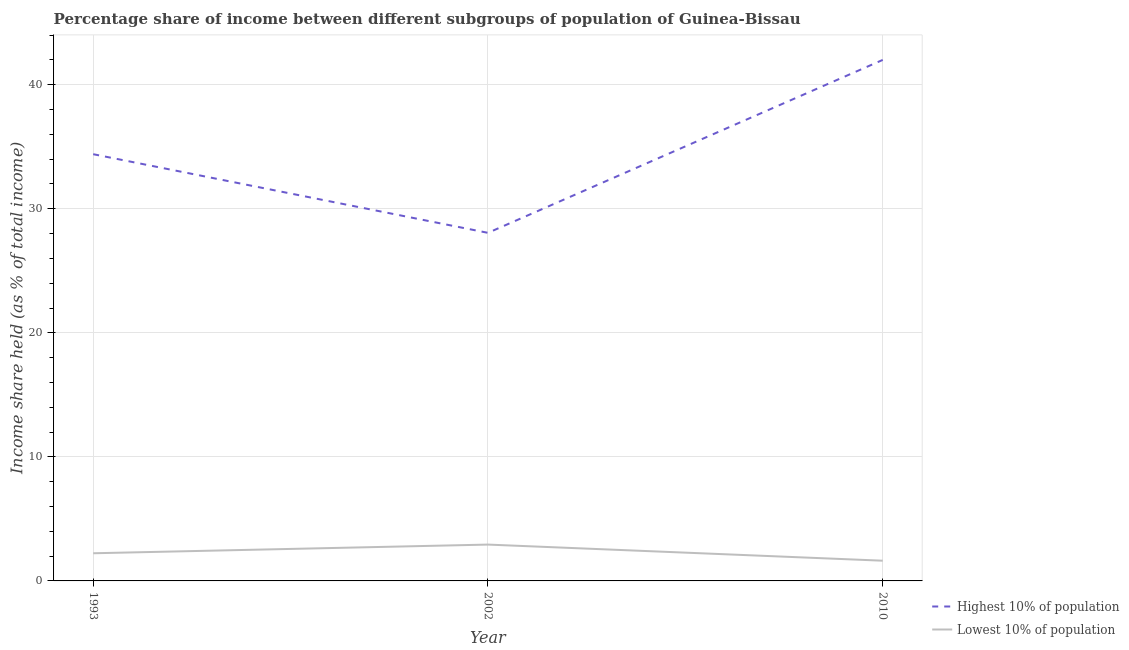Does the line corresponding to income share held by lowest 10% of the population intersect with the line corresponding to income share held by highest 10% of the population?
Provide a short and direct response. No. What is the income share held by lowest 10% of the population in 2002?
Give a very brief answer. 2.93. Across all years, what is the maximum income share held by highest 10% of the population?
Offer a terse response. 42. Across all years, what is the minimum income share held by highest 10% of the population?
Make the answer very short. 28.06. In which year was the income share held by lowest 10% of the population maximum?
Your answer should be very brief. 2002. In which year was the income share held by highest 10% of the population minimum?
Offer a very short reply. 2002. What is the total income share held by lowest 10% of the population in the graph?
Provide a short and direct response. 6.79. What is the difference between the income share held by lowest 10% of the population in 2002 and that in 2010?
Offer a terse response. 1.3. What is the difference between the income share held by lowest 10% of the population in 1993 and the income share held by highest 10% of the population in 2010?
Keep it short and to the point. -39.77. What is the average income share held by highest 10% of the population per year?
Your answer should be very brief. 34.82. In the year 2010, what is the difference between the income share held by lowest 10% of the population and income share held by highest 10% of the population?
Give a very brief answer. -40.37. What is the ratio of the income share held by highest 10% of the population in 1993 to that in 2010?
Your answer should be very brief. 0.82. Is the income share held by lowest 10% of the population in 1993 less than that in 2002?
Your response must be concise. Yes. Is the difference between the income share held by lowest 10% of the population in 1993 and 2010 greater than the difference between the income share held by highest 10% of the population in 1993 and 2010?
Offer a very short reply. Yes. What is the difference between the highest and the second highest income share held by highest 10% of the population?
Offer a very short reply. 7.6. What is the difference between the highest and the lowest income share held by highest 10% of the population?
Keep it short and to the point. 13.94. In how many years, is the income share held by lowest 10% of the population greater than the average income share held by lowest 10% of the population taken over all years?
Offer a terse response. 1. Does the income share held by lowest 10% of the population monotonically increase over the years?
Make the answer very short. No. Is the income share held by lowest 10% of the population strictly greater than the income share held by highest 10% of the population over the years?
Provide a short and direct response. No. Is the income share held by highest 10% of the population strictly less than the income share held by lowest 10% of the population over the years?
Provide a succinct answer. No. How many lines are there?
Provide a short and direct response. 2. Are the values on the major ticks of Y-axis written in scientific E-notation?
Provide a succinct answer. No. Where does the legend appear in the graph?
Keep it short and to the point. Bottom right. How many legend labels are there?
Give a very brief answer. 2. What is the title of the graph?
Provide a succinct answer. Percentage share of income between different subgroups of population of Guinea-Bissau. Does "Chemicals" appear as one of the legend labels in the graph?
Offer a very short reply. No. What is the label or title of the X-axis?
Your answer should be very brief. Year. What is the label or title of the Y-axis?
Give a very brief answer. Income share held (as % of total income). What is the Income share held (as % of total income) of Highest 10% of population in 1993?
Keep it short and to the point. 34.4. What is the Income share held (as % of total income) in Lowest 10% of population in 1993?
Make the answer very short. 2.23. What is the Income share held (as % of total income) of Highest 10% of population in 2002?
Offer a terse response. 28.06. What is the Income share held (as % of total income) in Lowest 10% of population in 2002?
Your answer should be very brief. 2.93. What is the Income share held (as % of total income) of Highest 10% of population in 2010?
Provide a short and direct response. 42. What is the Income share held (as % of total income) in Lowest 10% of population in 2010?
Your answer should be very brief. 1.63. Across all years, what is the maximum Income share held (as % of total income) of Highest 10% of population?
Provide a succinct answer. 42. Across all years, what is the maximum Income share held (as % of total income) in Lowest 10% of population?
Provide a short and direct response. 2.93. Across all years, what is the minimum Income share held (as % of total income) in Highest 10% of population?
Your answer should be compact. 28.06. Across all years, what is the minimum Income share held (as % of total income) in Lowest 10% of population?
Provide a succinct answer. 1.63. What is the total Income share held (as % of total income) in Highest 10% of population in the graph?
Offer a terse response. 104.46. What is the total Income share held (as % of total income) in Lowest 10% of population in the graph?
Offer a terse response. 6.79. What is the difference between the Income share held (as % of total income) in Highest 10% of population in 1993 and that in 2002?
Offer a very short reply. 6.34. What is the difference between the Income share held (as % of total income) in Lowest 10% of population in 1993 and that in 2002?
Make the answer very short. -0.7. What is the difference between the Income share held (as % of total income) of Highest 10% of population in 1993 and that in 2010?
Provide a short and direct response. -7.6. What is the difference between the Income share held (as % of total income) in Lowest 10% of population in 1993 and that in 2010?
Make the answer very short. 0.6. What is the difference between the Income share held (as % of total income) in Highest 10% of population in 2002 and that in 2010?
Ensure brevity in your answer.  -13.94. What is the difference between the Income share held (as % of total income) of Highest 10% of population in 1993 and the Income share held (as % of total income) of Lowest 10% of population in 2002?
Keep it short and to the point. 31.47. What is the difference between the Income share held (as % of total income) in Highest 10% of population in 1993 and the Income share held (as % of total income) in Lowest 10% of population in 2010?
Provide a succinct answer. 32.77. What is the difference between the Income share held (as % of total income) of Highest 10% of population in 2002 and the Income share held (as % of total income) of Lowest 10% of population in 2010?
Offer a very short reply. 26.43. What is the average Income share held (as % of total income) in Highest 10% of population per year?
Your answer should be compact. 34.82. What is the average Income share held (as % of total income) in Lowest 10% of population per year?
Your answer should be compact. 2.26. In the year 1993, what is the difference between the Income share held (as % of total income) of Highest 10% of population and Income share held (as % of total income) of Lowest 10% of population?
Offer a very short reply. 32.17. In the year 2002, what is the difference between the Income share held (as % of total income) in Highest 10% of population and Income share held (as % of total income) in Lowest 10% of population?
Provide a succinct answer. 25.13. In the year 2010, what is the difference between the Income share held (as % of total income) of Highest 10% of population and Income share held (as % of total income) of Lowest 10% of population?
Your response must be concise. 40.37. What is the ratio of the Income share held (as % of total income) in Highest 10% of population in 1993 to that in 2002?
Give a very brief answer. 1.23. What is the ratio of the Income share held (as % of total income) in Lowest 10% of population in 1993 to that in 2002?
Keep it short and to the point. 0.76. What is the ratio of the Income share held (as % of total income) in Highest 10% of population in 1993 to that in 2010?
Provide a short and direct response. 0.82. What is the ratio of the Income share held (as % of total income) of Lowest 10% of population in 1993 to that in 2010?
Your response must be concise. 1.37. What is the ratio of the Income share held (as % of total income) of Highest 10% of population in 2002 to that in 2010?
Your answer should be very brief. 0.67. What is the ratio of the Income share held (as % of total income) of Lowest 10% of population in 2002 to that in 2010?
Ensure brevity in your answer.  1.8. What is the difference between the highest and the second highest Income share held (as % of total income) in Highest 10% of population?
Offer a terse response. 7.6. What is the difference between the highest and the lowest Income share held (as % of total income) of Highest 10% of population?
Keep it short and to the point. 13.94. What is the difference between the highest and the lowest Income share held (as % of total income) of Lowest 10% of population?
Provide a short and direct response. 1.3. 